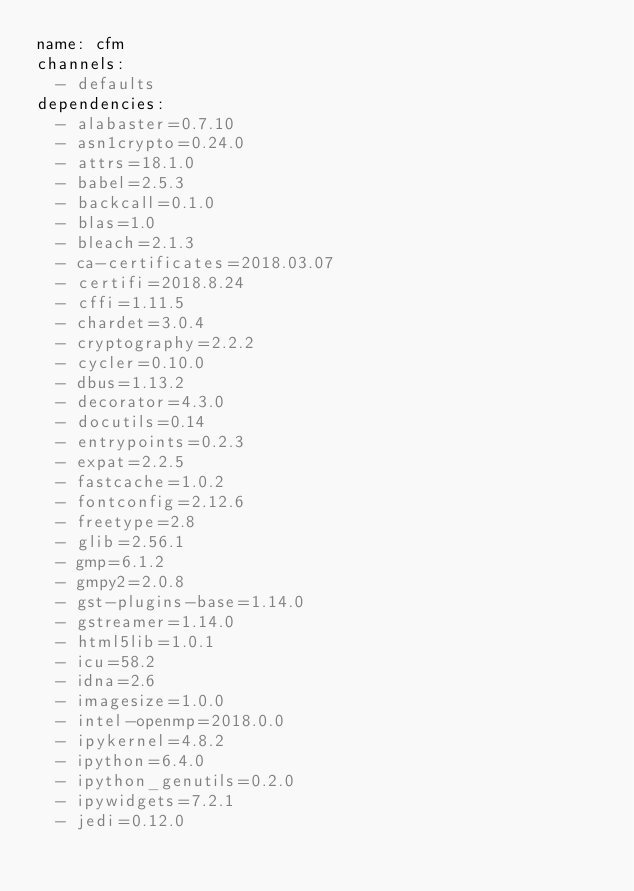<code> <loc_0><loc_0><loc_500><loc_500><_YAML_>name: cfm
channels:
  - defaults
dependencies:
  - alabaster=0.7.10
  - asn1crypto=0.24.0
  - attrs=18.1.0
  - babel=2.5.3
  - backcall=0.1.0
  - blas=1.0
  - bleach=2.1.3
  - ca-certificates=2018.03.07
  - certifi=2018.8.24
  - cffi=1.11.5
  - chardet=3.0.4
  - cryptography=2.2.2
  - cycler=0.10.0
  - dbus=1.13.2
  - decorator=4.3.0
  - docutils=0.14
  - entrypoints=0.2.3
  - expat=2.2.5
  - fastcache=1.0.2
  - fontconfig=2.12.6
  - freetype=2.8
  - glib=2.56.1
  - gmp=6.1.2
  - gmpy2=2.0.8
  - gst-plugins-base=1.14.0
  - gstreamer=1.14.0
  - html5lib=1.0.1
  - icu=58.2
  - idna=2.6
  - imagesize=1.0.0
  - intel-openmp=2018.0.0
  - ipykernel=4.8.2
  - ipython=6.4.0
  - ipython_genutils=0.2.0
  - ipywidgets=7.2.1
  - jedi=0.12.0</code> 